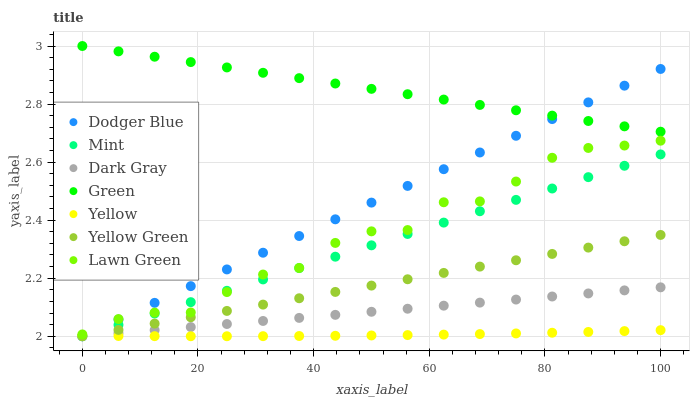Does Yellow have the minimum area under the curve?
Answer yes or no. Yes. Does Green have the maximum area under the curve?
Answer yes or no. Yes. Does Yellow Green have the minimum area under the curve?
Answer yes or no. No. Does Yellow Green have the maximum area under the curve?
Answer yes or no. No. Is Mint the smoothest?
Answer yes or no. Yes. Is Lawn Green the roughest?
Answer yes or no. Yes. Is Yellow Green the smoothest?
Answer yes or no. No. Is Yellow Green the roughest?
Answer yes or no. No. Does Yellow Green have the lowest value?
Answer yes or no. Yes. Does Yellow have the lowest value?
Answer yes or no. No. Does Green have the highest value?
Answer yes or no. Yes. Does Yellow Green have the highest value?
Answer yes or no. No. Is Yellow less than Lawn Green?
Answer yes or no. Yes. Is Green greater than Dark Gray?
Answer yes or no. Yes. Does Mint intersect Dodger Blue?
Answer yes or no. Yes. Is Mint less than Dodger Blue?
Answer yes or no. No. Is Mint greater than Dodger Blue?
Answer yes or no. No. Does Yellow intersect Lawn Green?
Answer yes or no. No. 